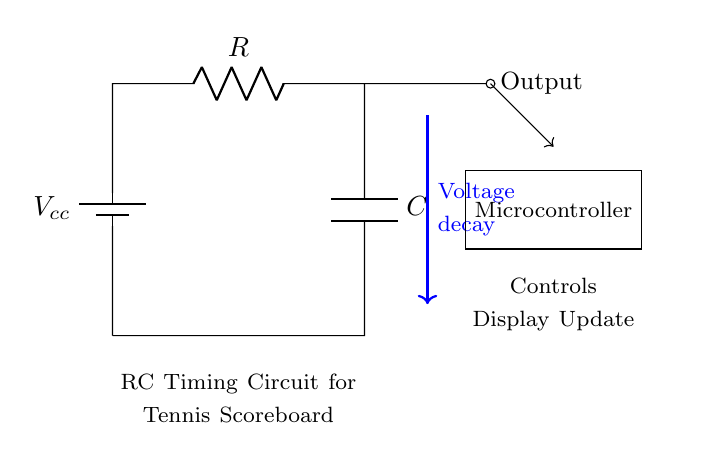What components are present in the circuit? The circuit contains a battery, a resistor, and a capacitor, which are essential components for the RC timing circuit.
Answer: battery, resistor, capacitor What does the output signify? The output indicates the voltage decay over time as the capacitor discharges through the resistor. This is crucial for timing intervals in the scoreboard.
Answer: Voltage decay What is the function of the microcontroller? The microcontroller processes the output signal from the RC circuit and controls the display updates on the scoreboard.
Answer: Controls display update What is the relationship between resistance and timing in this circuit? The timing in this RC circuit is influenced by the resistance value; a higher resistance increases the time constant, leading to slower decay of the voltage.
Answer: Higher resistance equals slower timing How does the capacitor affect the voltage in the circuit? As the capacitor charges, it stores voltage, and when it discharges, it releases that voltage over time, causing the output voltage to decay.
Answer: Stores and releases voltage What type of circuit is this? This is a timing circuit specifically used for applications such as scoreboards in sports, where precise timing intervals are necessary.
Answer: RC timing circuit What is the purpose of the resistor in the RC timing circuit? The resistor limits the current flow in the circuit and helps to determine the rate at which the capacitor charges and discharges, defining the timing characteristic.
Answer: Limits current flow 